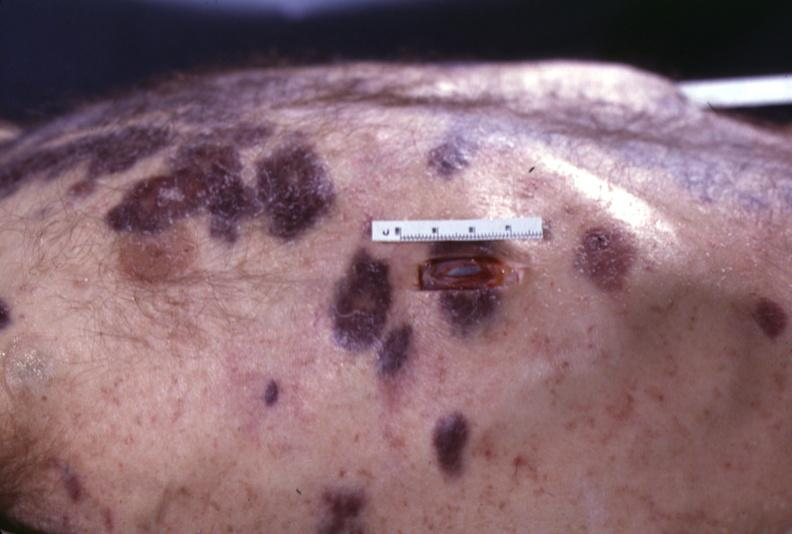does carcinomatosis endometrium primary show skin, kaposi 's sarcoma?
Answer the question using a single word or phrase. No 